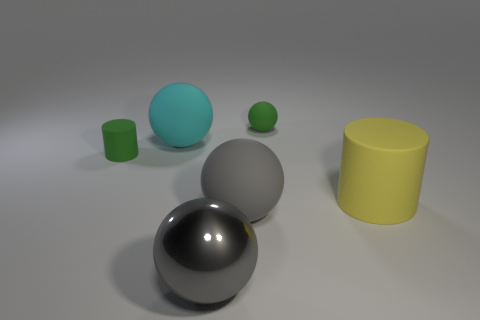What number of objects are rubber objects that are behind the big cylinder or green matte cylinders? In the image, there are two rubber objects behind the big yellow cylinder, which are a small green cylinder and a green sphere. Additionally, there are two green matte cylinders in the scene. Therefore, the total number of objects that are either rubber objects behind the big cylinder or green matte cylinders is four. 